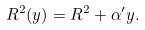Convert formula to latex. <formula><loc_0><loc_0><loc_500><loc_500>R ^ { 2 } ( y ) = R ^ { 2 } + \alpha ^ { \prime } y .</formula> 